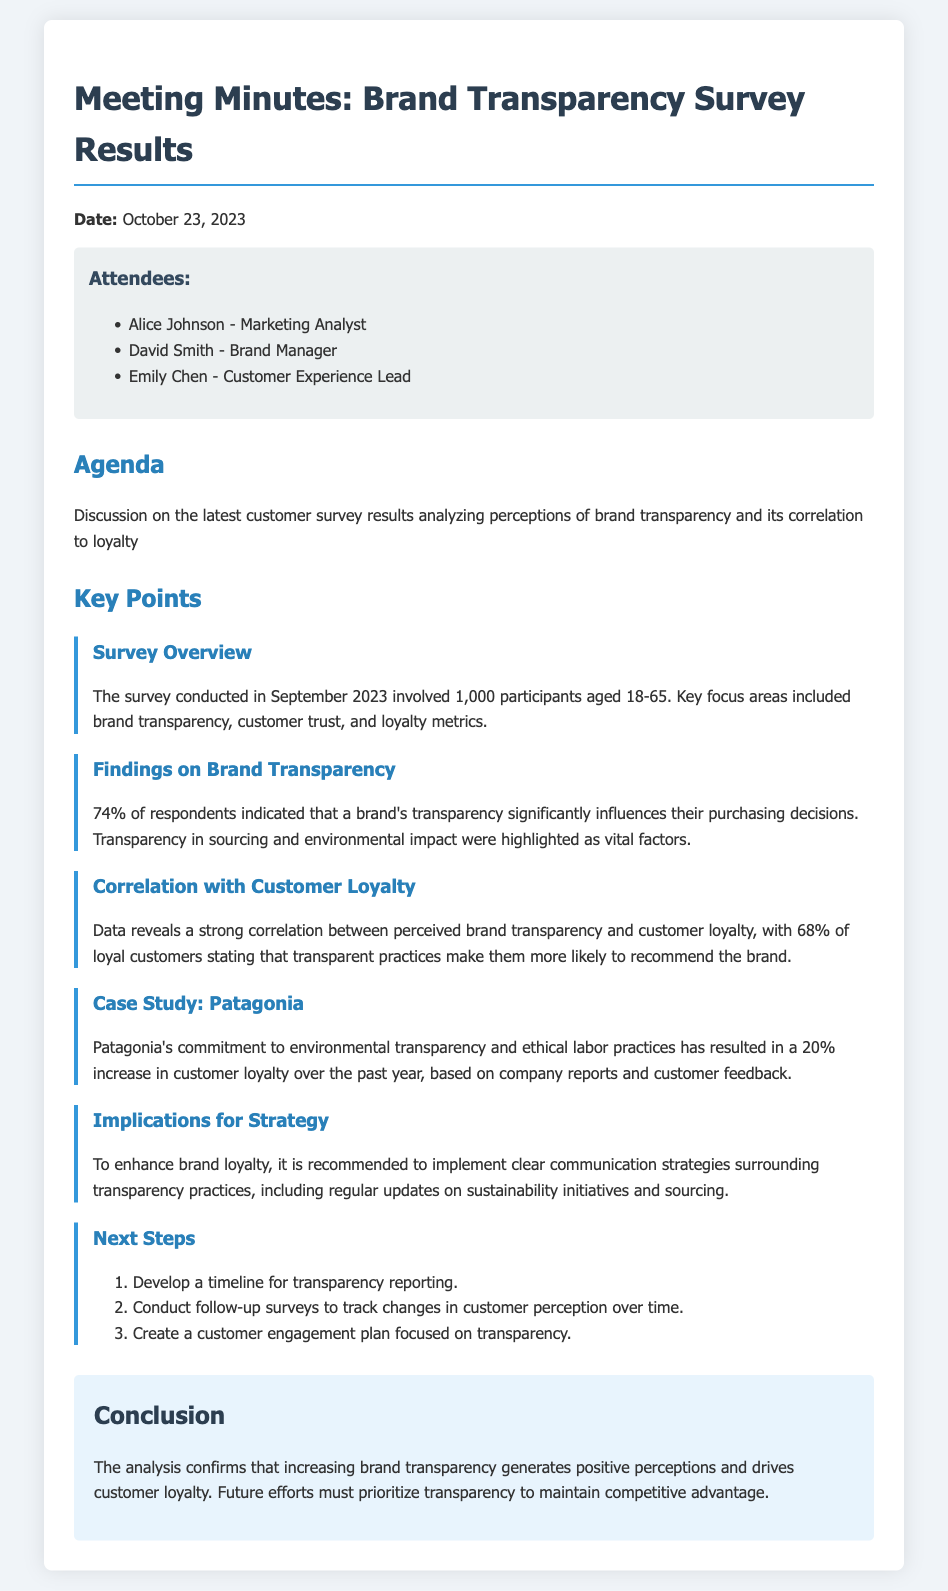What was the date of the meeting? The date of the meeting is mentioned at the beginning of the document.
Answer: October 23, 2023 Who conducted the survey? The document does not specify a name but states the survey was conducted in September 2023.
Answer: Not specified How many participants were involved in the survey? The document provides the total number of participants that took part in the survey.
Answer: 1,000 What percentage of respondents indicated that transparency influences purchasing decisions? The document specifies the percentage of respondents that highlighted the importance of transparency.
Answer: 74% What correlation exists between perceived transparency and customer loyalty? The document provides a statistic related to customer loyalty in connection with transparency.
Answer: Strong correlation Which company is mentioned as a case study? The document references a specific company recognized for its transparent practices.
Answer: Patagonia What is one recommendation to enhance brand loyalty? The document outlines a strategy recommendation to improve loyalty related to transparency.
Answer: Clear communication strategies What is one of the next steps mentioned for improving transparency? The document lists actions as next steps towards enhancing transparency in brand practices.
Answer: Develop a timeline for transparency reporting What percentage of loyal customers said transparent practices influence their recommendations? The document articulates the percentage of loyal customers who noted the impact of transparency on recommendations.
Answer: 68% 